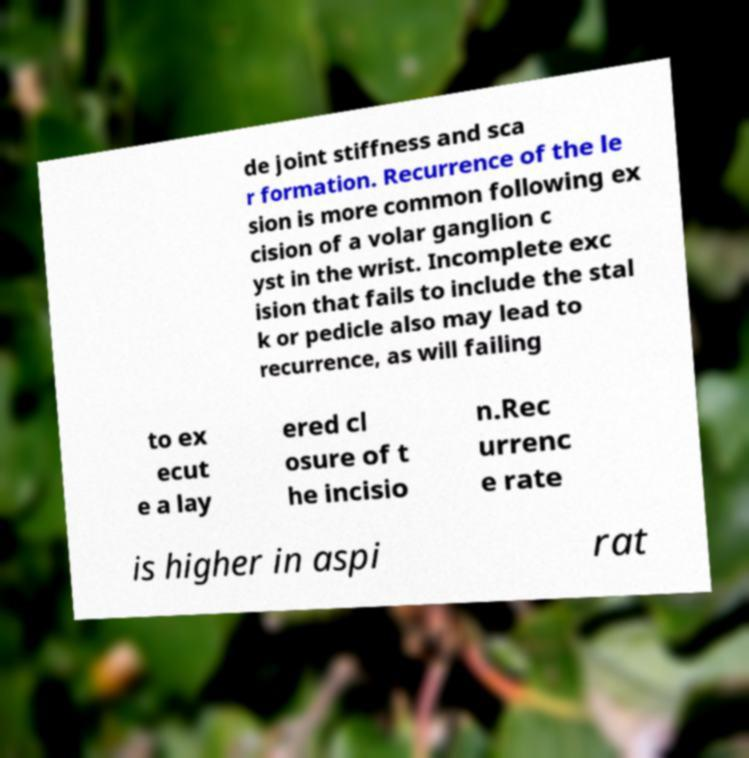Please identify and transcribe the text found in this image. de joint stiffness and sca r formation. Recurrence of the le sion is more common following ex cision of a volar ganglion c yst in the wrist. Incomplete exc ision that fails to include the stal k or pedicle also may lead to recurrence, as will failing to ex ecut e a lay ered cl osure of t he incisio n.Rec urrenc e rate is higher in aspi rat 